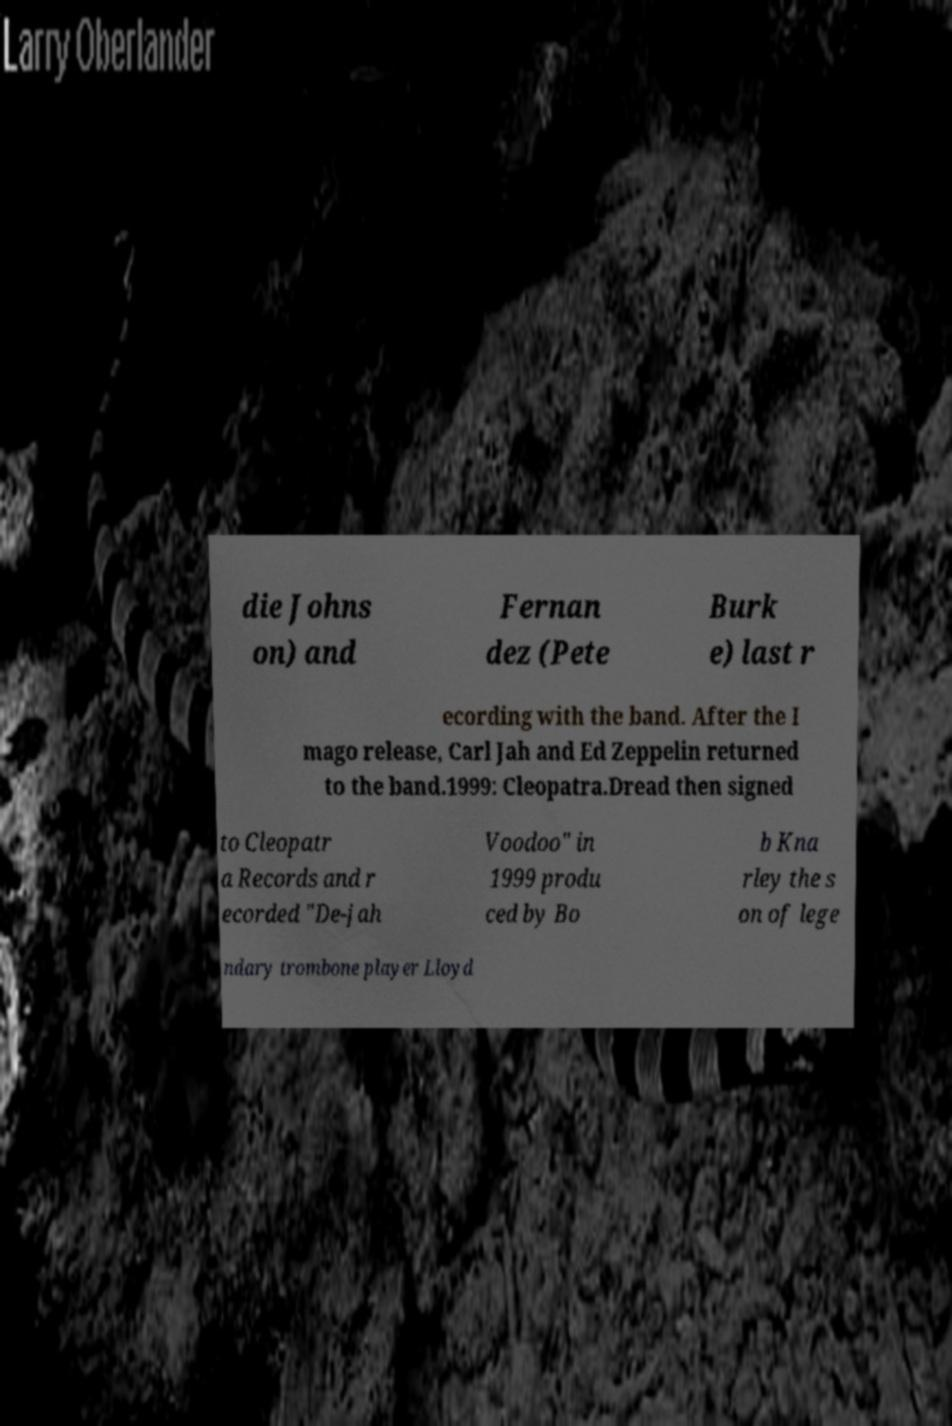What messages or text are displayed in this image? I need them in a readable, typed format. die Johns on) and Fernan dez (Pete Burk e) last r ecording with the band. After the I mago release, Carl Jah and Ed Zeppelin returned to the band.1999: Cleopatra.Dread then signed to Cleopatr a Records and r ecorded "De-jah Voodoo" in 1999 produ ced by Bo b Kna rley the s on of lege ndary trombone player Lloyd 